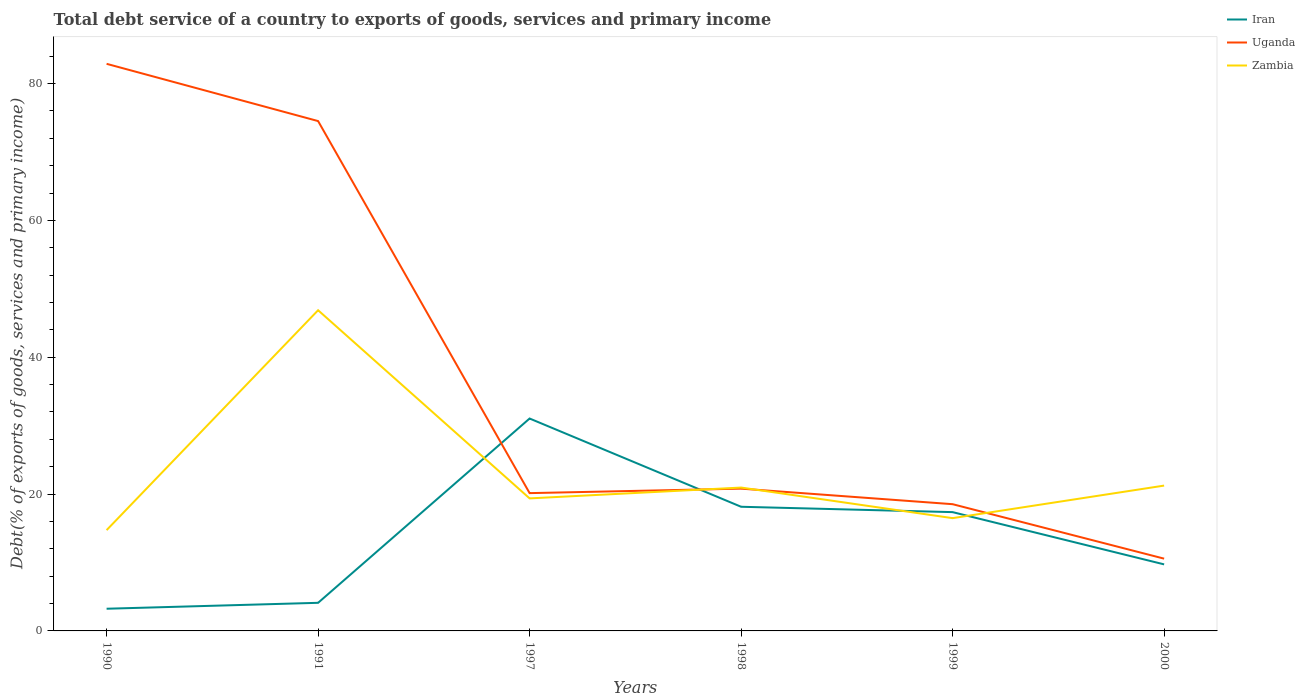How many different coloured lines are there?
Provide a short and direct response. 3. Does the line corresponding to Uganda intersect with the line corresponding to Iran?
Provide a short and direct response. Yes. Is the number of lines equal to the number of legend labels?
Provide a succinct answer. Yes. Across all years, what is the maximum total debt service in Zambia?
Give a very brief answer. 14.73. In which year was the total debt service in Iran maximum?
Keep it short and to the point. 1990. What is the total total debt service in Iran in the graph?
Ensure brevity in your answer.  -14.12. What is the difference between the highest and the second highest total debt service in Uganda?
Your response must be concise. 72.33. How many years are there in the graph?
Keep it short and to the point. 6. Does the graph contain any zero values?
Offer a terse response. No. Where does the legend appear in the graph?
Your response must be concise. Top right. What is the title of the graph?
Provide a succinct answer. Total debt service of a country to exports of goods, services and primary income. Does "Russian Federation" appear as one of the legend labels in the graph?
Give a very brief answer. No. What is the label or title of the X-axis?
Your response must be concise. Years. What is the label or title of the Y-axis?
Your response must be concise. Debt(% of exports of goods, services and primary income). What is the Debt(% of exports of goods, services and primary income) in Iran in 1990?
Ensure brevity in your answer.  3.24. What is the Debt(% of exports of goods, services and primary income) of Uganda in 1990?
Keep it short and to the point. 82.89. What is the Debt(% of exports of goods, services and primary income) of Zambia in 1990?
Provide a short and direct response. 14.73. What is the Debt(% of exports of goods, services and primary income) of Iran in 1991?
Offer a very short reply. 4.11. What is the Debt(% of exports of goods, services and primary income) in Uganda in 1991?
Keep it short and to the point. 74.53. What is the Debt(% of exports of goods, services and primary income) in Zambia in 1991?
Offer a very short reply. 46.88. What is the Debt(% of exports of goods, services and primary income) in Iran in 1997?
Give a very brief answer. 31.05. What is the Debt(% of exports of goods, services and primary income) in Uganda in 1997?
Your answer should be very brief. 20.14. What is the Debt(% of exports of goods, services and primary income) in Zambia in 1997?
Make the answer very short. 19.37. What is the Debt(% of exports of goods, services and primary income) in Iran in 1998?
Your answer should be very brief. 18.15. What is the Debt(% of exports of goods, services and primary income) in Uganda in 1998?
Your response must be concise. 20.8. What is the Debt(% of exports of goods, services and primary income) in Zambia in 1998?
Make the answer very short. 20.96. What is the Debt(% of exports of goods, services and primary income) in Iran in 1999?
Provide a succinct answer. 17.36. What is the Debt(% of exports of goods, services and primary income) of Uganda in 1999?
Make the answer very short. 18.52. What is the Debt(% of exports of goods, services and primary income) in Zambia in 1999?
Offer a terse response. 16.48. What is the Debt(% of exports of goods, services and primary income) of Iran in 2000?
Your answer should be very brief. 9.73. What is the Debt(% of exports of goods, services and primary income) in Uganda in 2000?
Provide a short and direct response. 10.56. What is the Debt(% of exports of goods, services and primary income) of Zambia in 2000?
Make the answer very short. 21.24. Across all years, what is the maximum Debt(% of exports of goods, services and primary income) of Iran?
Your answer should be compact. 31.05. Across all years, what is the maximum Debt(% of exports of goods, services and primary income) of Uganda?
Make the answer very short. 82.89. Across all years, what is the maximum Debt(% of exports of goods, services and primary income) of Zambia?
Your answer should be compact. 46.88. Across all years, what is the minimum Debt(% of exports of goods, services and primary income) in Iran?
Your answer should be very brief. 3.24. Across all years, what is the minimum Debt(% of exports of goods, services and primary income) in Uganda?
Your answer should be very brief. 10.56. Across all years, what is the minimum Debt(% of exports of goods, services and primary income) in Zambia?
Your answer should be compact. 14.73. What is the total Debt(% of exports of goods, services and primary income) in Iran in the graph?
Your response must be concise. 83.64. What is the total Debt(% of exports of goods, services and primary income) of Uganda in the graph?
Your answer should be very brief. 227.45. What is the total Debt(% of exports of goods, services and primary income) in Zambia in the graph?
Give a very brief answer. 139.66. What is the difference between the Debt(% of exports of goods, services and primary income) in Iran in 1990 and that in 1991?
Keep it short and to the point. -0.87. What is the difference between the Debt(% of exports of goods, services and primary income) of Uganda in 1990 and that in 1991?
Your answer should be very brief. 8.37. What is the difference between the Debt(% of exports of goods, services and primary income) in Zambia in 1990 and that in 1991?
Offer a very short reply. -32.14. What is the difference between the Debt(% of exports of goods, services and primary income) of Iran in 1990 and that in 1997?
Give a very brief answer. -27.81. What is the difference between the Debt(% of exports of goods, services and primary income) in Uganda in 1990 and that in 1997?
Your answer should be very brief. 62.75. What is the difference between the Debt(% of exports of goods, services and primary income) of Zambia in 1990 and that in 1997?
Your answer should be very brief. -4.64. What is the difference between the Debt(% of exports of goods, services and primary income) in Iran in 1990 and that in 1998?
Give a very brief answer. -14.91. What is the difference between the Debt(% of exports of goods, services and primary income) in Uganda in 1990 and that in 1998?
Provide a succinct answer. 62.1. What is the difference between the Debt(% of exports of goods, services and primary income) in Zambia in 1990 and that in 1998?
Your answer should be compact. -6.22. What is the difference between the Debt(% of exports of goods, services and primary income) of Iran in 1990 and that in 1999?
Keep it short and to the point. -14.12. What is the difference between the Debt(% of exports of goods, services and primary income) in Uganda in 1990 and that in 1999?
Provide a succinct answer. 64.37. What is the difference between the Debt(% of exports of goods, services and primary income) in Zambia in 1990 and that in 1999?
Your answer should be compact. -1.75. What is the difference between the Debt(% of exports of goods, services and primary income) in Iran in 1990 and that in 2000?
Provide a short and direct response. -6.48. What is the difference between the Debt(% of exports of goods, services and primary income) in Uganda in 1990 and that in 2000?
Keep it short and to the point. 72.33. What is the difference between the Debt(% of exports of goods, services and primary income) of Zambia in 1990 and that in 2000?
Give a very brief answer. -6.51. What is the difference between the Debt(% of exports of goods, services and primary income) in Iran in 1991 and that in 1997?
Ensure brevity in your answer.  -26.94. What is the difference between the Debt(% of exports of goods, services and primary income) in Uganda in 1991 and that in 1997?
Your response must be concise. 54.38. What is the difference between the Debt(% of exports of goods, services and primary income) of Zambia in 1991 and that in 1997?
Your answer should be very brief. 27.5. What is the difference between the Debt(% of exports of goods, services and primary income) in Iran in 1991 and that in 1998?
Your answer should be compact. -14.04. What is the difference between the Debt(% of exports of goods, services and primary income) in Uganda in 1991 and that in 1998?
Your answer should be compact. 53.73. What is the difference between the Debt(% of exports of goods, services and primary income) in Zambia in 1991 and that in 1998?
Keep it short and to the point. 25.92. What is the difference between the Debt(% of exports of goods, services and primary income) in Iran in 1991 and that in 1999?
Keep it short and to the point. -13.26. What is the difference between the Debt(% of exports of goods, services and primary income) in Uganda in 1991 and that in 1999?
Your answer should be compact. 56. What is the difference between the Debt(% of exports of goods, services and primary income) of Zambia in 1991 and that in 1999?
Ensure brevity in your answer.  30.39. What is the difference between the Debt(% of exports of goods, services and primary income) in Iran in 1991 and that in 2000?
Your answer should be compact. -5.62. What is the difference between the Debt(% of exports of goods, services and primary income) of Uganda in 1991 and that in 2000?
Provide a short and direct response. 63.96. What is the difference between the Debt(% of exports of goods, services and primary income) in Zambia in 1991 and that in 2000?
Your answer should be very brief. 25.63. What is the difference between the Debt(% of exports of goods, services and primary income) in Iran in 1997 and that in 1998?
Keep it short and to the point. 12.9. What is the difference between the Debt(% of exports of goods, services and primary income) in Uganda in 1997 and that in 1998?
Give a very brief answer. -0.65. What is the difference between the Debt(% of exports of goods, services and primary income) of Zambia in 1997 and that in 1998?
Offer a terse response. -1.58. What is the difference between the Debt(% of exports of goods, services and primary income) of Iran in 1997 and that in 1999?
Provide a succinct answer. 13.68. What is the difference between the Debt(% of exports of goods, services and primary income) in Uganda in 1997 and that in 1999?
Offer a very short reply. 1.62. What is the difference between the Debt(% of exports of goods, services and primary income) in Zambia in 1997 and that in 1999?
Give a very brief answer. 2.89. What is the difference between the Debt(% of exports of goods, services and primary income) of Iran in 1997 and that in 2000?
Give a very brief answer. 21.32. What is the difference between the Debt(% of exports of goods, services and primary income) in Uganda in 1997 and that in 2000?
Keep it short and to the point. 9.58. What is the difference between the Debt(% of exports of goods, services and primary income) in Zambia in 1997 and that in 2000?
Ensure brevity in your answer.  -1.87. What is the difference between the Debt(% of exports of goods, services and primary income) in Iran in 1998 and that in 1999?
Give a very brief answer. 0.78. What is the difference between the Debt(% of exports of goods, services and primary income) of Uganda in 1998 and that in 1999?
Your answer should be very brief. 2.27. What is the difference between the Debt(% of exports of goods, services and primary income) in Zambia in 1998 and that in 1999?
Provide a short and direct response. 4.47. What is the difference between the Debt(% of exports of goods, services and primary income) of Iran in 1998 and that in 2000?
Offer a terse response. 8.42. What is the difference between the Debt(% of exports of goods, services and primary income) of Uganda in 1998 and that in 2000?
Ensure brevity in your answer.  10.23. What is the difference between the Debt(% of exports of goods, services and primary income) of Zambia in 1998 and that in 2000?
Offer a very short reply. -0.29. What is the difference between the Debt(% of exports of goods, services and primary income) in Iran in 1999 and that in 2000?
Provide a short and direct response. 7.64. What is the difference between the Debt(% of exports of goods, services and primary income) in Uganda in 1999 and that in 2000?
Give a very brief answer. 7.96. What is the difference between the Debt(% of exports of goods, services and primary income) of Zambia in 1999 and that in 2000?
Keep it short and to the point. -4.76. What is the difference between the Debt(% of exports of goods, services and primary income) in Iran in 1990 and the Debt(% of exports of goods, services and primary income) in Uganda in 1991?
Make the answer very short. -71.28. What is the difference between the Debt(% of exports of goods, services and primary income) of Iran in 1990 and the Debt(% of exports of goods, services and primary income) of Zambia in 1991?
Make the answer very short. -43.63. What is the difference between the Debt(% of exports of goods, services and primary income) of Uganda in 1990 and the Debt(% of exports of goods, services and primary income) of Zambia in 1991?
Offer a very short reply. 36.02. What is the difference between the Debt(% of exports of goods, services and primary income) of Iran in 1990 and the Debt(% of exports of goods, services and primary income) of Uganda in 1997?
Provide a short and direct response. -16.9. What is the difference between the Debt(% of exports of goods, services and primary income) in Iran in 1990 and the Debt(% of exports of goods, services and primary income) in Zambia in 1997?
Your answer should be very brief. -16.13. What is the difference between the Debt(% of exports of goods, services and primary income) of Uganda in 1990 and the Debt(% of exports of goods, services and primary income) of Zambia in 1997?
Give a very brief answer. 63.52. What is the difference between the Debt(% of exports of goods, services and primary income) in Iran in 1990 and the Debt(% of exports of goods, services and primary income) in Uganda in 1998?
Provide a succinct answer. -17.55. What is the difference between the Debt(% of exports of goods, services and primary income) of Iran in 1990 and the Debt(% of exports of goods, services and primary income) of Zambia in 1998?
Ensure brevity in your answer.  -17.71. What is the difference between the Debt(% of exports of goods, services and primary income) of Uganda in 1990 and the Debt(% of exports of goods, services and primary income) of Zambia in 1998?
Your answer should be very brief. 61.94. What is the difference between the Debt(% of exports of goods, services and primary income) in Iran in 1990 and the Debt(% of exports of goods, services and primary income) in Uganda in 1999?
Your answer should be very brief. -15.28. What is the difference between the Debt(% of exports of goods, services and primary income) of Iran in 1990 and the Debt(% of exports of goods, services and primary income) of Zambia in 1999?
Provide a succinct answer. -13.24. What is the difference between the Debt(% of exports of goods, services and primary income) of Uganda in 1990 and the Debt(% of exports of goods, services and primary income) of Zambia in 1999?
Provide a short and direct response. 66.41. What is the difference between the Debt(% of exports of goods, services and primary income) of Iran in 1990 and the Debt(% of exports of goods, services and primary income) of Uganda in 2000?
Give a very brief answer. -7.32. What is the difference between the Debt(% of exports of goods, services and primary income) in Iran in 1990 and the Debt(% of exports of goods, services and primary income) in Zambia in 2000?
Offer a terse response. -18. What is the difference between the Debt(% of exports of goods, services and primary income) of Uganda in 1990 and the Debt(% of exports of goods, services and primary income) of Zambia in 2000?
Offer a terse response. 61.65. What is the difference between the Debt(% of exports of goods, services and primary income) of Iran in 1991 and the Debt(% of exports of goods, services and primary income) of Uganda in 1997?
Your answer should be very brief. -16.03. What is the difference between the Debt(% of exports of goods, services and primary income) in Iran in 1991 and the Debt(% of exports of goods, services and primary income) in Zambia in 1997?
Provide a short and direct response. -15.26. What is the difference between the Debt(% of exports of goods, services and primary income) of Uganda in 1991 and the Debt(% of exports of goods, services and primary income) of Zambia in 1997?
Provide a short and direct response. 55.15. What is the difference between the Debt(% of exports of goods, services and primary income) of Iran in 1991 and the Debt(% of exports of goods, services and primary income) of Uganda in 1998?
Your answer should be compact. -16.69. What is the difference between the Debt(% of exports of goods, services and primary income) of Iran in 1991 and the Debt(% of exports of goods, services and primary income) of Zambia in 1998?
Offer a very short reply. -16.85. What is the difference between the Debt(% of exports of goods, services and primary income) of Uganda in 1991 and the Debt(% of exports of goods, services and primary income) of Zambia in 1998?
Your response must be concise. 53.57. What is the difference between the Debt(% of exports of goods, services and primary income) of Iran in 1991 and the Debt(% of exports of goods, services and primary income) of Uganda in 1999?
Your answer should be very brief. -14.42. What is the difference between the Debt(% of exports of goods, services and primary income) of Iran in 1991 and the Debt(% of exports of goods, services and primary income) of Zambia in 1999?
Ensure brevity in your answer.  -12.38. What is the difference between the Debt(% of exports of goods, services and primary income) of Uganda in 1991 and the Debt(% of exports of goods, services and primary income) of Zambia in 1999?
Ensure brevity in your answer.  58.04. What is the difference between the Debt(% of exports of goods, services and primary income) in Iran in 1991 and the Debt(% of exports of goods, services and primary income) in Uganda in 2000?
Make the answer very short. -6.46. What is the difference between the Debt(% of exports of goods, services and primary income) in Iran in 1991 and the Debt(% of exports of goods, services and primary income) in Zambia in 2000?
Provide a succinct answer. -17.14. What is the difference between the Debt(% of exports of goods, services and primary income) in Uganda in 1991 and the Debt(% of exports of goods, services and primary income) in Zambia in 2000?
Give a very brief answer. 53.28. What is the difference between the Debt(% of exports of goods, services and primary income) in Iran in 1997 and the Debt(% of exports of goods, services and primary income) in Uganda in 1998?
Provide a short and direct response. 10.25. What is the difference between the Debt(% of exports of goods, services and primary income) of Iran in 1997 and the Debt(% of exports of goods, services and primary income) of Zambia in 1998?
Your answer should be compact. 10.09. What is the difference between the Debt(% of exports of goods, services and primary income) in Uganda in 1997 and the Debt(% of exports of goods, services and primary income) in Zambia in 1998?
Make the answer very short. -0.81. What is the difference between the Debt(% of exports of goods, services and primary income) in Iran in 1997 and the Debt(% of exports of goods, services and primary income) in Uganda in 1999?
Your answer should be very brief. 12.52. What is the difference between the Debt(% of exports of goods, services and primary income) in Iran in 1997 and the Debt(% of exports of goods, services and primary income) in Zambia in 1999?
Provide a short and direct response. 14.56. What is the difference between the Debt(% of exports of goods, services and primary income) of Uganda in 1997 and the Debt(% of exports of goods, services and primary income) of Zambia in 1999?
Ensure brevity in your answer.  3.66. What is the difference between the Debt(% of exports of goods, services and primary income) in Iran in 1997 and the Debt(% of exports of goods, services and primary income) in Uganda in 2000?
Your response must be concise. 20.48. What is the difference between the Debt(% of exports of goods, services and primary income) in Iran in 1997 and the Debt(% of exports of goods, services and primary income) in Zambia in 2000?
Your answer should be very brief. 9.81. What is the difference between the Debt(% of exports of goods, services and primary income) of Uganda in 1997 and the Debt(% of exports of goods, services and primary income) of Zambia in 2000?
Keep it short and to the point. -1.1. What is the difference between the Debt(% of exports of goods, services and primary income) of Iran in 1998 and the Debt(% of exports of goods, services and primary income) of Uganda in 1999?
Offer a very short reply. -0.38. What is the difference between the Debt(% of exports of goods, services and primary income) in Iran in 1998 and the Debt(% of exports of goods, services and primary income) in Zambia in 1999?
Offer a very short reply. 1.66. What is the difference between the Debt(% of exports of goods, services and primary income) in Uganda in 1998 and the Debt(% of exports of goods, services and primary income) in Zambia in 1999?
Offer a terse response. 4.31. What is the difference between the Debt(% of exports of goods, services and primary income) in Iran in 1998 and the Debt(% of exports of goods, services and primary income) in Uganda in 2000?
Your answer should be very brief. 7.58. What is the difference between the Debt(% of exports of goods, services and primary income) in Iran in 1998 and the Debt(% of exports of goods, services and primary income) in Zambia in 2000?
Your answer should be compact. -3.09. What is the difference between the Debt(% of exports of goods, services and primary income) in Uganda in 1998 and the Debt(% of exports of goods, services and primary income) in Zambia in 2000?
Provide a succinct answer. -0.45. What is the difference between the Debt(% of exports of goods, services and primary income) of Iran in 1999 and the Debt(% of exports of goods, services and primary income) of Uganda in 2000?
Offer a very short reply. 6.8. What is the difference between the Debt(% of exports of goods, services and primary income) in Iran in 1999 and the Debt(% of exports of goods, services and primary income) in Zambia in 2000?
Give a very brief answer. -3.88. What is the difference between the Debt(% of exports of goods, services and primary income) in Uganda in 1999 and the Debt(% of exports of goods, services and primary income) in Zambia in 2000?
Keep it short and to the point. -2.72. What is the average Debt(% of exports of goods, services and primary income) in Iran per year?
Give a very brief answer. 13.94. What is the average Debt(% of exports of goods, services and primary income) in Uganda per year?
Make the answer very short. 37.91. What is the average Debt(% of exports of goods, services and primary income) of Zambia per year?
Provide a succinct answer. 23.28. In the year 1990, what is the difference between the Debt(% of exports of goods, services and primary income) in Iran and Debt(% of exports of goods, services and primary income) in Uganda?
Offer a terse response. -79.65. In the year 1990, what is the difference between the Debt(% of exports of goods, services and primary income) of Iran and Debt(% of exports of goods, services and primary income) of Zambia?
Your response must be concise. -11.49. In the year 1990, what is the difference between the Debt(% of exports of goods, services and primary income) of Uganda and Debt(% of exports of goods, services and primary income) of Zambia?
Give a very brief answer. 68.16. In the year 1991, what is the difference between the Debt(% of exports of goods, services and primary income) in Iran and Debt(% of exports of goods, services and primary income) in Uganda?
Give a very brief answer. -70.42. In the year 1991, what is the difference between the Debt(% of exports of goods, services and primary income) in Iran and Debt(% of exports of goods, services and primary income) in Zambia?
Make the answer very short. -42.77. In the year 1991, what is the difference between the Debt(% of exports of goods, services and primary income) in Uganda and Debt(% of exports of goods, services and primary income) in Zambia?
Give a very brief answer. 27.65. In the year 1997, what is the difference between the Debt(% of exports of goods, services and primary income) of Iran and Debt(% of exports of goods, services and primary income) of Uganda?
Your response must be concise. 10.91. In the year 1997, what is the difference between the Debt(% of exports of goods, services and primary income) in Iran and Debt(% of exports of goods, services and primary income) in Zambia?
Offer a terse response. 11.68. In the year 1997, what is the difference between the Debt(% of exports of goods, services and primary income) in Uganda and Debt(% of exports of goods, services and primary income) in Zambia?
Make the answer very short. 0.77. In the year 1998, what is the difference between the Debt(% of exports of goods, services and primary income) in Iran and Debt(% of exports of goods, services and primary income) in Uganda?
Your answer should be very brief. -2.65. In the year 1998, what is the difference between the Debt(% of exports of goods, services and primary income) of Iran and Debt(% of exports of goods, services and primary income) of Zambia?
Ensure brevity in your answer.  -2.81. In the year 1998, what is the difference between the Debt(% of exports of goods, services and primary income) of Uganda and Debt(% of exports of goods, services and primary income) of Zambia?
Ensure brevity in your answer.  -0.16. In the year 1999, what is the difference between the Debt(% of exports of goods, services and primary income) of Iran and Debt(% of exports of goods, services and primary income) of Uganda?
Your answer should be compact. -1.16. In the year 1999, what is the difference between the Debt(% of exports of goods, services and primary income) in Iran and Debt(% of exports of goods, services and primary income) in Zambia?
Ensure brevity in your answer.  0.88. In the year 1999, what is the difference between the Debt(% of exports of goods, services and primary income) in Uganda and Debt(% of exports of goods, services and primary income) in Zambia?
Your response must be concise. 2.04. In the year 2000, what is the difference between the Debt(% of exports of goods, services and primary income) of Iran and Debt(% of exports of goods, services and primary income) of Uganda?
Offer a terse response. -0.84. In the year 2000, what is the difference between the Debt(% of exports of goods, services and primary income) of Iran and Debt(% of exports of goods, services and primary income) of Zambia?
Make the answer very short. -11.52. In the year 2000, what is the difference between the Debt(% of exports of goods, services and primary income) of Uganda and Debt(% of exports of goods, services and primary income) of Zambia?
Make the answer very short. -10.68. What is the ratio of the Debt(% of exports of goods, services and primary income) in Iran in 1990 to that in 1991?
Give a very brief answer. 0.79. What is the ratio of the Debt(% of exports of goods, services and primary income) in Uganda in 1990 to that in 1991?
Keep it short and to the point. 1.11. What is the ratio of the Debt(% of exports of goods, services and primary income) in Zambia in 1990 to that in 1991?
Your response must be concise. 0.31. What is the ratio of the Debt(% of exports of goods, services and primary income) of Iran in 1990 to that in 1997?
Ensure brevity in your answer.  0.1. What is the ratio of the Debt(% of exports of goods, services and primary income) of Uganda in 1990 to that in 1997?
Your answer should be compact. 4.12. What is the ratio of the Debt(% of exports of goods, services and primary income) in Zambia in 1990 to that in 1997?
Your answer should be very brief. 0.76. What is the ratio of the Debt(% of exports of goods, services and primary income) of Iran in 1990 to that in 1998?
Make the answer very short. 0.18. What is the ratio of the Debt(% of exports of goods, services and primary income) of Uganda in 1990 to that in 1998?
Keep it short and to the point. 3.99. What is the ratio of the Debt(% of exports of goods, services and primary income) in Zambia in 1990 to that in 1998?
Ensure brevity in your answer.  0.7. What is the ratio of the Debt(% of exports of goods, services and primary income) of Iran in 1990 to that in 1999?
Your response must be concise. 0.19. What is the ratio of the Debt(% of exports of goods, services and primary income) of Uganda in 1990 to that in 1999?
Your response must be concise. 4.47. What is the ratio of the Debt(% of exports of goods, services and primary income) in Zambia in 1990 to that in 1999?
Provide a short and direct response. 0.89. What is the ratio of the Debt(% of exports of goods, services and primary income) in Uganda in 1990 to that in 2000?
Keep it short and to the point. 7.85. What is the ratio of the Debt(% of exports of goods, services and primary income) of Zambia in 1990 to that in 2000?
Give a very brief answer. 0.69. What is the ratio of the Debt(% of exports of goods, services and primary income) of Iran in 1991 to that in 1997?
Provide a short and direct response. 0.13. What is the ratio of the Debt(% of exports of goods, services and primary income) in Zambia in 1991 to that in 1997?
Your answer should be compact. 2.42. What is the ratio of the Debt(% of exports of goods, services and primary income) in Iran in 1991 to that in 1998?
Offer a terse response. 0.23. What is the ratio of the Debt(% of exports of goods, services and primary income) in Uganda in 1991 to that in 1998?
Your answer should be very brief. 3.58. What is the ratio of the Debt(% of exports of goods, services and primary income) in Zambia in 1991 to that in 1998?
Make the answer very short. 2.24. What is the ratio of the Debt(% of exports of goods, services and primary income) of Iran in 1991 to that in 1999?
Ensure brevity in your answer.  0.24. What is the ratio of the Debt(% of exports of goods, services and primary income) of Uganda in 1991 to that in 1999?
Offer a terse response. 4.02. What is the ratio of the Debt(% of exports of goods, services and primary income) of Zambia in 1991 to that in 1999?
Your answer should be compact. 2.84. What is the ratio of the Debt(% of exports of goods, services and primary income) of Iran in 1991 to that in 2000?
Your answer should be very brief. 0.42. What is the ratio of the Debt(% of exports of goods, services and primary income) in Uganda in 1991 to that in 2000?
Offer a terse response. 7.05. What is the ratio of the Debt(% of exports of goods, services and primary income) in Zambia in 1991 to that in 2000?
Offer a very short reply. 2.21. What is the ratio of the Debt(% of exports of goods, services and primary income) of Iran in 1997 to that in 1998?
Keep it short and to the point. 1.71. What is the ratio of the Debt(% of exports of goods, services and primary income) of Uganda in 1997 to that in 1998?
Provide a succinct answer. 0.97. What is the ratio of the Debt(% of exports of goods, services and primary income) in Zambia in 1997 to that in 1998?
Your response must be concise. 0.92. What is the ratio of the Debt(% of exports of goods, services and primary income) of Iran in 1997 to that in 1999?
Your answer should be very brief. 1.79. What is the ratio of the Debt(% of exports of goods, services and primary income) of Uganda in 1997 to that in 1999?
Offer a terse response. 1.09. What is the ratio of the Debt(% of exports of goods, services and primary income) of Zambia in 1997 to that in 1999?
Offer a very short reply. 1.18. What is the ratio of the Debt(% of exports of goods, services and primary income) in Iran in 1997 to that in 2000?
Offer a terse response. 3.19. What is the ratio of the Debt(% of exports of goods, services and primary income) of Uganda in 1997 to that in 2000?
Keep it short and to the point. 1.91. What is the ratio of the Debt(% of exports of goods, services and primary income) in Zambia in 1997 to that in 2000?
Ensure brevity in your answer.  0.91. What is the ratio of the Debt(% of exports of goods, services and primary income) in Iran in 1998 to that in 1999?
Your answer should be compact. 1.05. What is the ratio of the Debt(% of exports of goods, services and primary income) in Uganda in 1998 to that in 1999?
Your answer should be very brief. 1.12. What is the ratio of the Debt(% of exports of goods, services and primary income) of Zambia in 1998 to that in 1999?
Your response must be concise. 1.27. What is the ratio of the Debt(% of exports of goods, services and primary income) in Iran in 1998 to that in 2000?
Make the answer very short. 1.87. What is the ratio of the Debt(% of exports of goods, services and primary income) of Uganda in 1998 to that in 2000?
Provide a succinct answer. 1.97. What is the ratio of the Debt(% of exports of goods, services and primary income) in Zambia in 1998 to that in 2000?
Offer a terse response. 0.99. What is the ratio of the Debt(% of exports of goods, services and primary income) in Iran in 1999 to that in 2000?
Provide a succinct answer. 1.79. What is the ratio of the Debt(% of exports of goods, services and primary income) of Uganda in 1999 to that in 2000?
Give a very brief answer. 1.75. What is the ratio of the Debt(% of exports of goods, services and primary income) of Zambia in 1999 to that in 2000?
Make the answer very short. 0.78. What is the difference between the highest and the second highest Debt(% of exports of goods, services and primary income) of Iran?
Offer a terse response. 12.9. What is the difference between the highest and the second highest Debt(% of exports of goods, services and primary income) in Uganda?
Keep it short and to the point. 8.37. What is the difference between the highest and the second highest Debt(% of exports of goods, services and primary income) of Zambia?
Ensure brevity in your answer.  25.63. What is the difference between the highest and the lowest Debt(% of exports of goods, services and primary income) of Iran?
Provide a short and direct response. 27.81. What is the difference between the highest and the lowest Debt(% of exports of goods, services and primary income) in Uganda?
Provide a succinct answer. 72.33. What is the difference between the highest and the lowest Debt(% of exports of goods, services and primary income) of Zambia?
Keep it short and to the point. 32.14. 